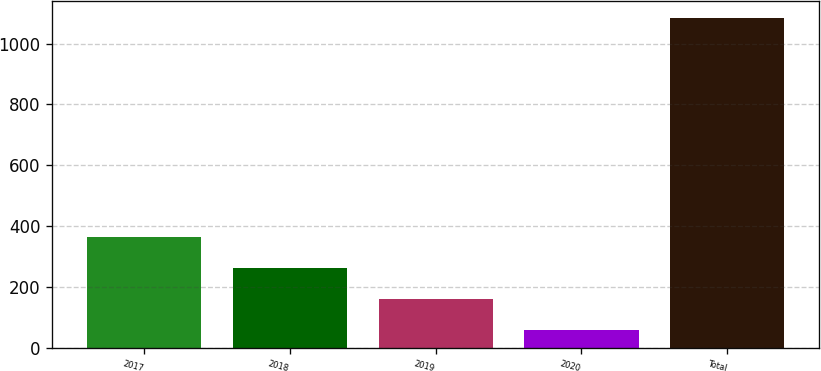Convert chart. <chart><loc_0><loc_0><loc_500><loc_500><bar_chart><fcel>2017<fcel>2018<fcel>2019<fcel>2020<fcel>Total<nl><fcel>365.8<fcel>263.2<fcel>160.6<fcel>58<fcel>1084<nl></chart> 